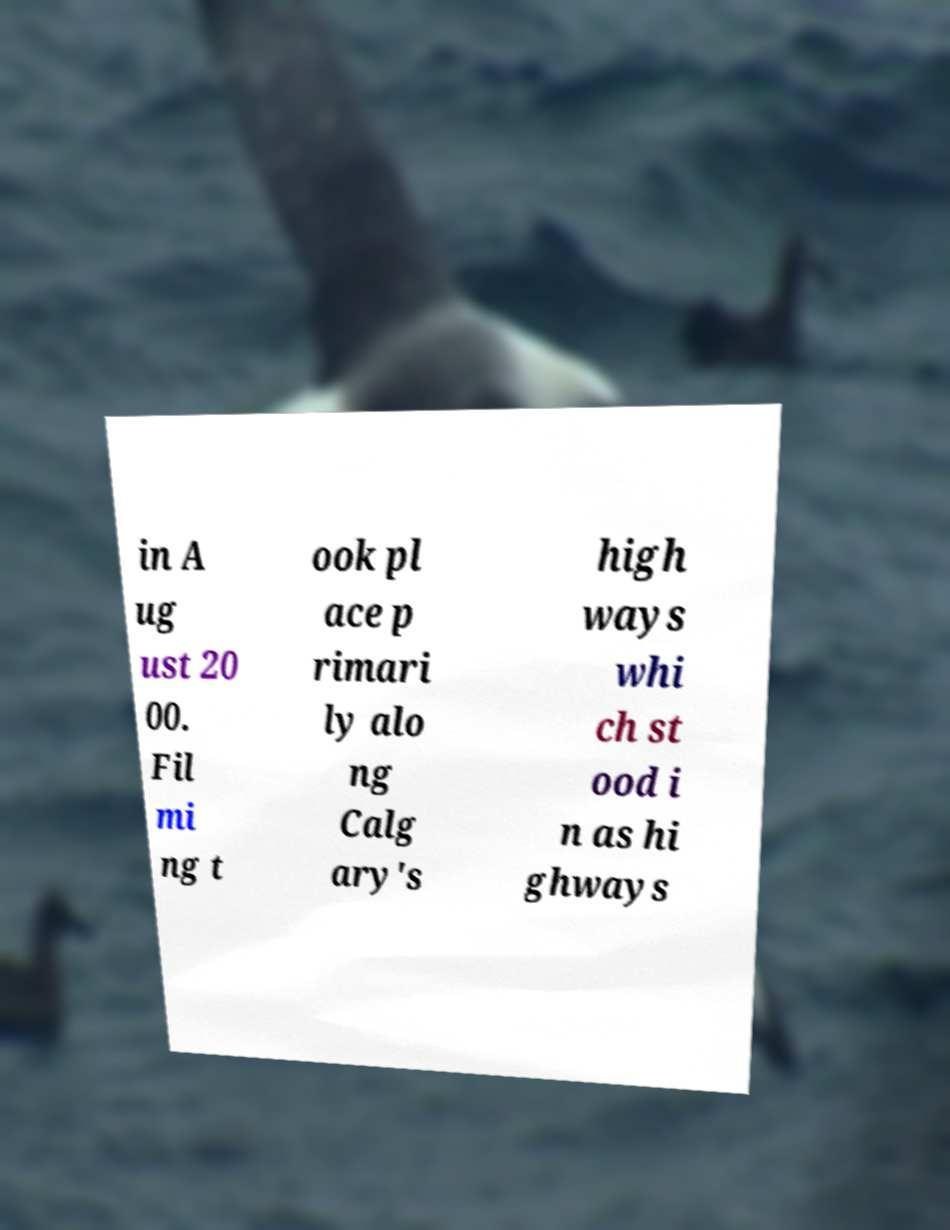What messages or text are displayed in this image? I need them in a readable, typed format. in A ug ust 20 00. Fil mi ng t ook pl ace p rimari ly alo ng Calg ary's high ways whi ch st ood i n as hi ghways 